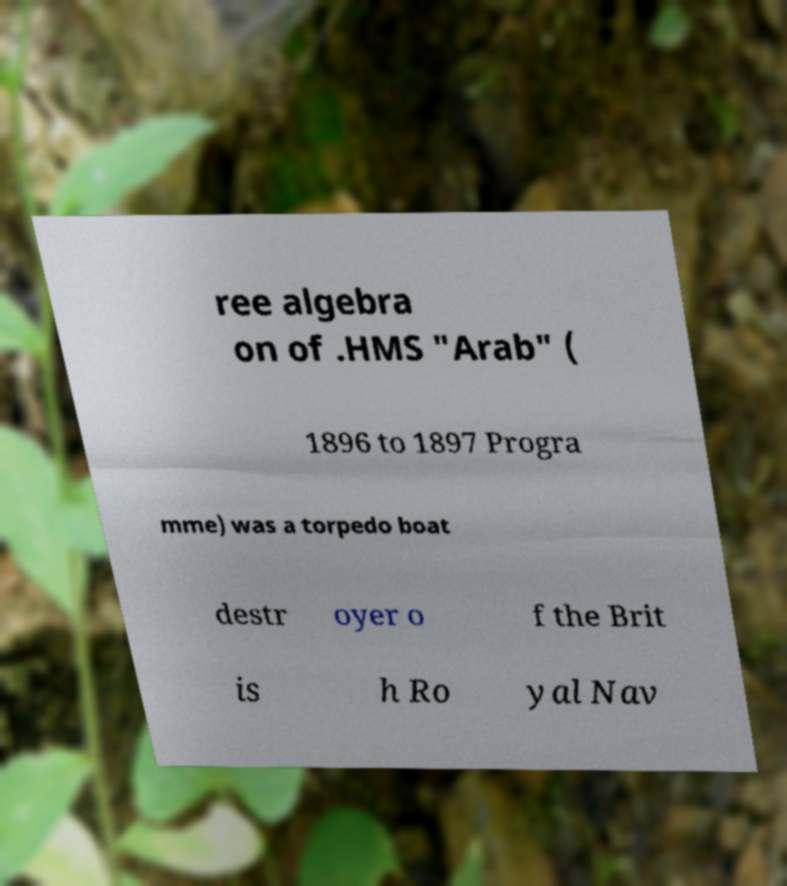Can you read and provide the text displayed in the image?This photo seems to have some interesting text. Can you extract and type it out for me? ree algebra on of .HMS "Arab" ( 1896 to 1897 Progra mme) was a torpedo boat destr oyer o f the Brit is h Ro yal Nav 